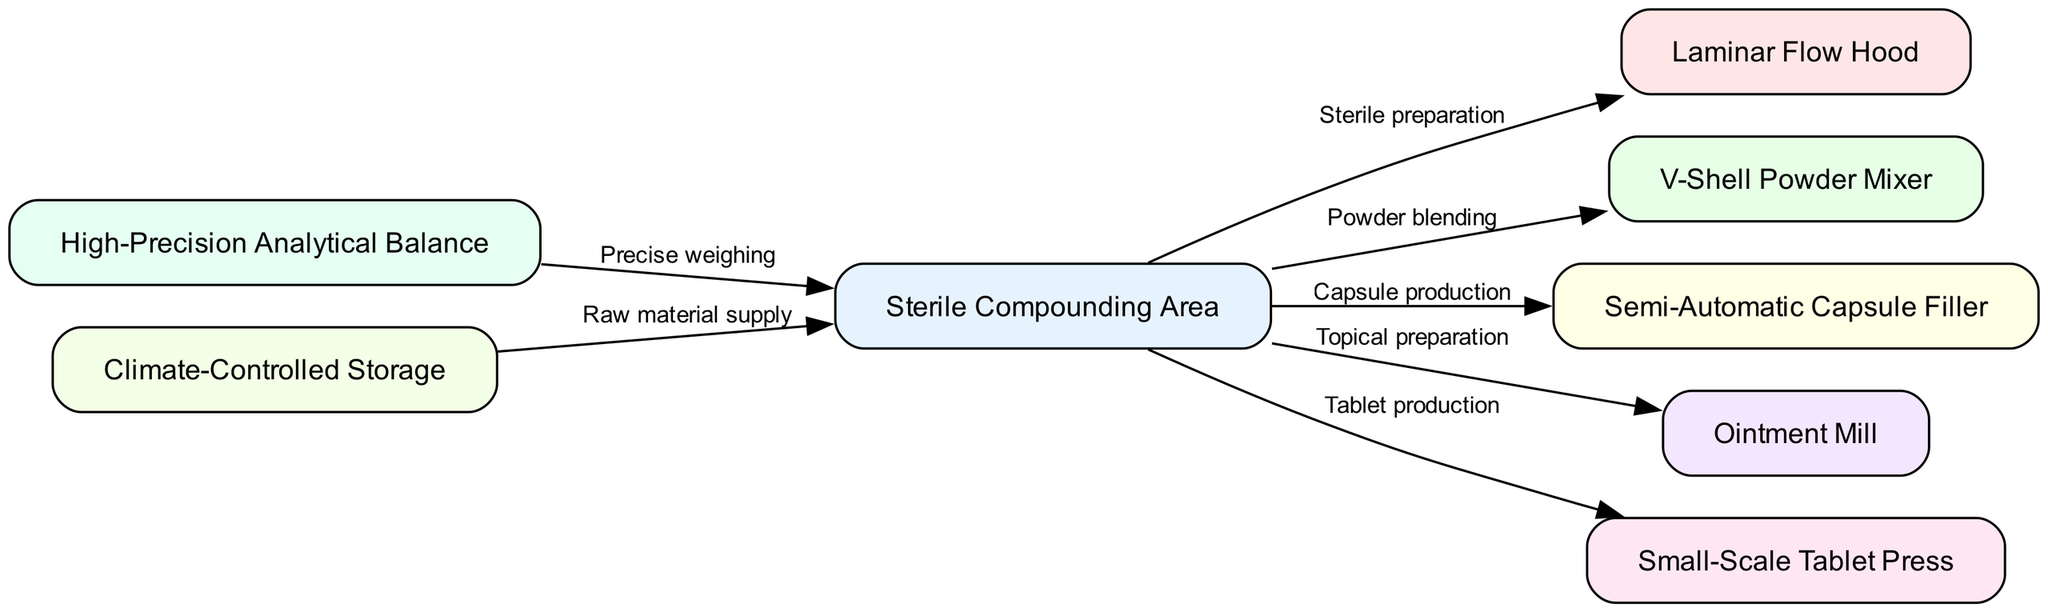What is the main area designated for compounding? The diagram shows that the "Sterile Compounding Area" is the central node, indicating it is the main area where all compounding activities take place.
Answer: Sterile Compounding Area How many major pieces of equipment are shown in the diagram? By counting the nodes in the diagram, there are eight distinct pieces of equipment represented, indicating the different functions available for small-scale pharmaceutical manufacturing.
Answer: 8 What type of equipment is used for sterile preparation? The diagram illustrates that the "Laminar Flow Hood" is directly connected to the "Sterile Compounding Area", signifying its role in ensuring sterile conditions during preparation.
Answer: Laminar Flow Hood Which equipment is associated with powder blending? The edge from "Sterile Compounding Area" to "V-Shell Powder Mixer" labeled "Powder blending" indicates that this piece of equipment is specifically used for this process.
Answer: V-Shell Powder Mixer What is the flow of raw material supply to compounding? The diagram shows an edge labeled "Raw material supply" from "Climate-Controlled Storage" to "Sterile Compounding Area", indicating that materials are supplied from storage for compounding processes.
Answer: Climate-Controlled Storage How many connections are made from the compounding area? The "Sterile Compounding Area" has five outgoing edges to different pieces of equipment, reflecting the various compounding processes initiated from this central location.
Answer: 5 What is the function of the High-Precision Analytical Balance? The diagram shows that the "High-Precision Analytical Balance" is connected to the "Sterile Compounding Area" with a label indicating "Precise weighing", indicating its function in ensuring accurate measurements in compounding.
Answer: Precise weighing Which equipment handles topical preparations? The edge labeled "Topical preparation" connects the "Sterile Compounding Area" to the "Ointment Mill", indicating that the ointment mill is utilized for preparing topical medications.
Answer: Ointment Mill What is the relationship between the semi-automatic capsule filler and the compounding area? The diagram shows a directed edge from "Sterile Compounding Area" to "Semi-Automatic Capsule Filler" labeled "Capsule production", indicating that this equipment is used for producing capsules as part of the compounding process.
Answer: Capsule production 